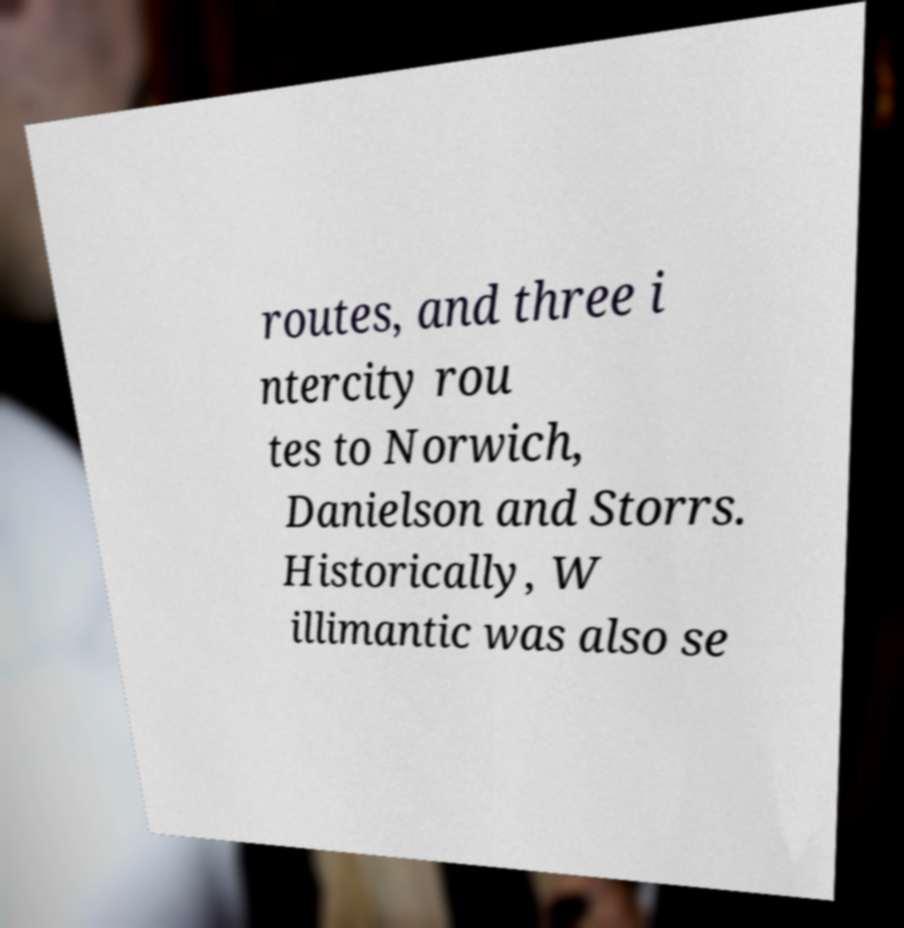Please read and relay the text visible in this image. What does it say? routes, and three i ntercity rou tes to Norwich, Danielson and Storrs. Historically, W illimantic was also se 